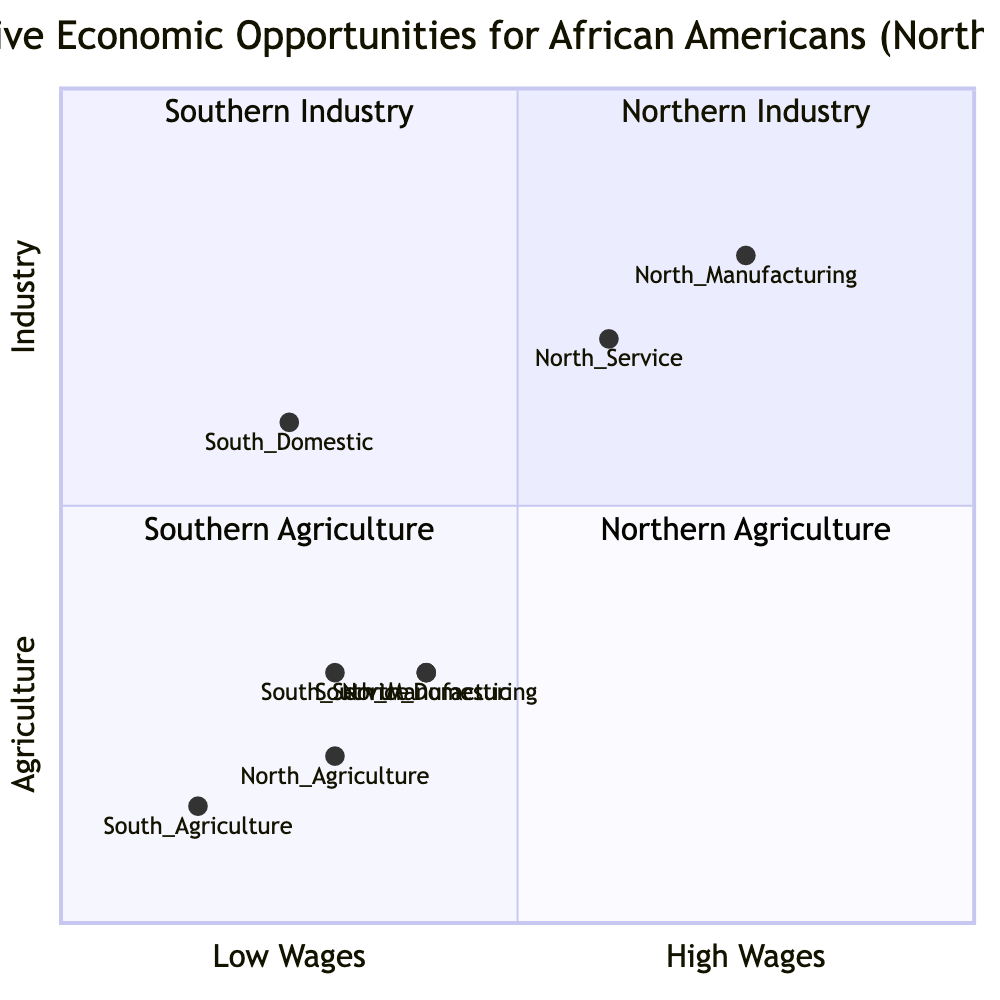What is the primary sector for African Americans in Northern regions? Examining the diagram, the coordinates for Northern Manufacturing indicate it falls in quadrant 1, which is categorized under Northern Industry. This is reinforced as it's the highest point in the manufacturing sector displayed.
Answer: Manufacturing Which quadrant primarily represents Southern Agriculture? The coordinates for Southern Agriculture are located in quadrant 3, which is identified as representing Southern Agriculture in the diagram.
Answer: Quadrant 3 What is the wage value for North Domestic jobs? Looking at the coordinates for North Domestic (0.4, 0.3), the wage value represented on the x-axis is 0.4. This relates directly to the location of North Domestic in relation to other sectors.
Answer: 0.4 Which employment sector has the highest wage in the South? Reviewing the South sectors, the coordinates for South Manufacturing (0.4, 0.3) indicate it has the highest wage, as it is positioned highest among other Southern sectors.
Answer: Manufacturing How many distinct employment sectors are represented for Northern regions? The diagram lists four distinct sectors for the North: Manufacturing, Service, Domestic, and Agriculture. Hence, counting these sectors gives us the total number.
Answer: 4 What relationship can be noted regarding Agricultural jobs in the North and South? Comparing the coordinates for Northern Agriculture (0.3, 0.2) and Southern Agriculture (0.15, 0.14), it is clear that Northern Agriculture has higher wages and industrial classification than Southern counterparts.
Answer: Northern jobs have higher wages Which region has a larger representation in the Industry sector? By comparing the heights of the Northern and Southern sectors, it's apparent that Northern Industry is represented more prominently at higher wage values when compared to Southern Industry.
Answer: North What is the wage difference between Southern Service and Northern Service? Looking at the coordinates, Southern Service (0.3, 0.3) and Northern Service (0.6, 0.7) have wage values of 0.3 and 0.6, respectively. The difference can be calculated directly based on these values.
Answer: 0.3 Which sector appears to have the lowest wage overall? Observing the diagram, Southern Agriculture has the lowest wage represented by the coordinates (0.15, 0.14), making it the lowest wage sector.
Answer: Southern Agriculture What is the wage coordinate for Northern Service jobs? Checking Northern Service's coordinates from the diagram shows its value as 0.6 on the x-axis. This provides a clear answer based on the position of Northern Service in the diagram.
Answer: 0.6 